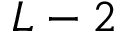<formula> <loc_0><loc_0><loc_500><loc_500>L - 2</formula> 